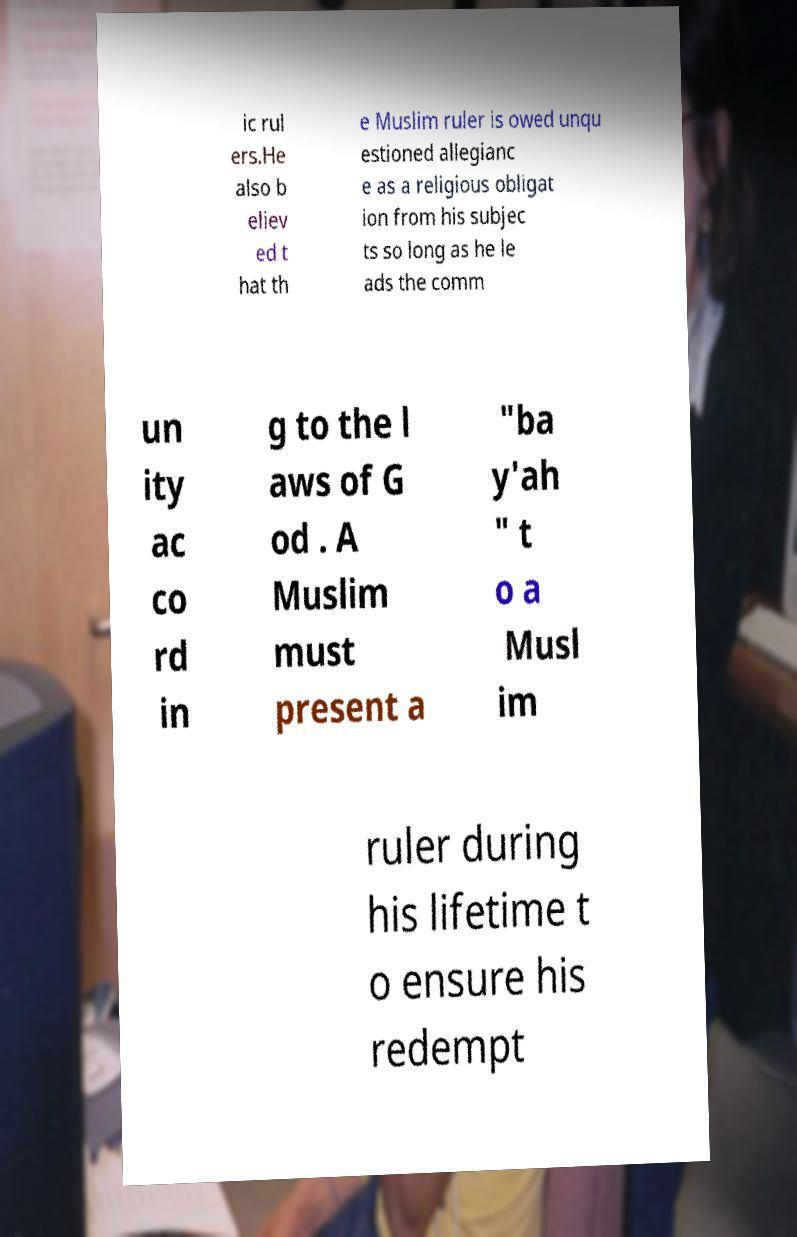There's text embedded in this image that I need extracted. Can you transcribe it verbatim? ic rul ers.He also b eliev ed t hat th e Muslim ruler is owed unqu estioned allegianc e as a religious obligat ion from his subjec ts so long as he le ads the comm un ity ac co rd in g to the l aws of G od . A Muslim must present a "ba y'ah " t o a Musl im ruler during his lifetime t o ensure his redempt 